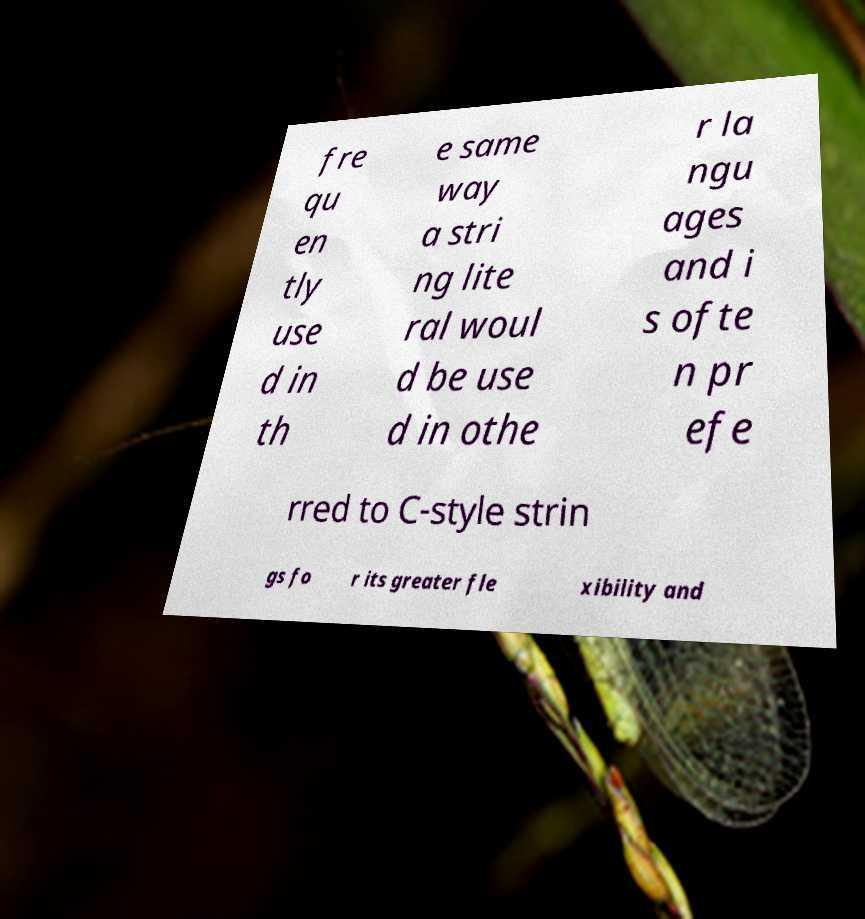Please identify and transcribe the text found in this image. fre qu en tly use d in th e same way a stri ng lite ral woul d be use d in othe r la ngu ages and i s ofte n pr efe rred to C-style strin gs fo r its greater fle xibility and 